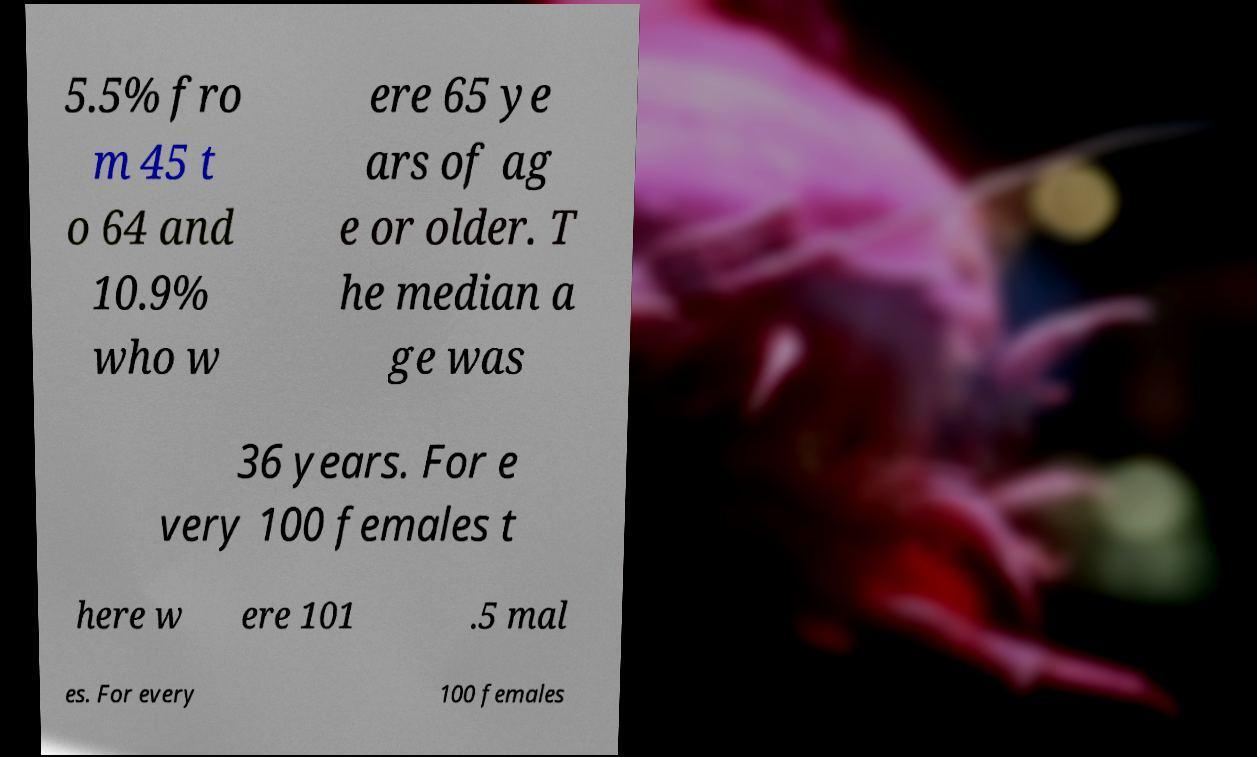Could you assist in decoding the text presented in this image and type it out clearly? 5.5% fro m 45 t o 64 and 10.9% who w ere 65 ye ars of ag e or older. T he median a ge was 36 years. For e very 100 females t here w ere 101 .5 mal es. For every 100 females 